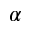<formula> <loc_0><loc_0><loc_500><loc_500>\alpha</formula> 